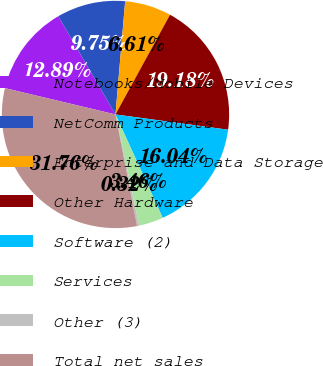Convert chart to OTSL. <chart><loc_0><loc_0><loc_500><loc_500><pie_chart><fcel>Notebooks/Mobile Devices<fcel>NetComm Products<fcel>Enterprise and Data Storage<fcel>Other Hardware<fcel>Software (2)<fcel>Services<fcel>Other (3)<fcel>Total net sales<nl><fcel>12.89%<fcel>9.75%<fcel>6.61%<fcel>19.18%<fcel>16.04%<fcel>3.46%<fcel>0.32%<fcel>31.76%<nl></chart> 